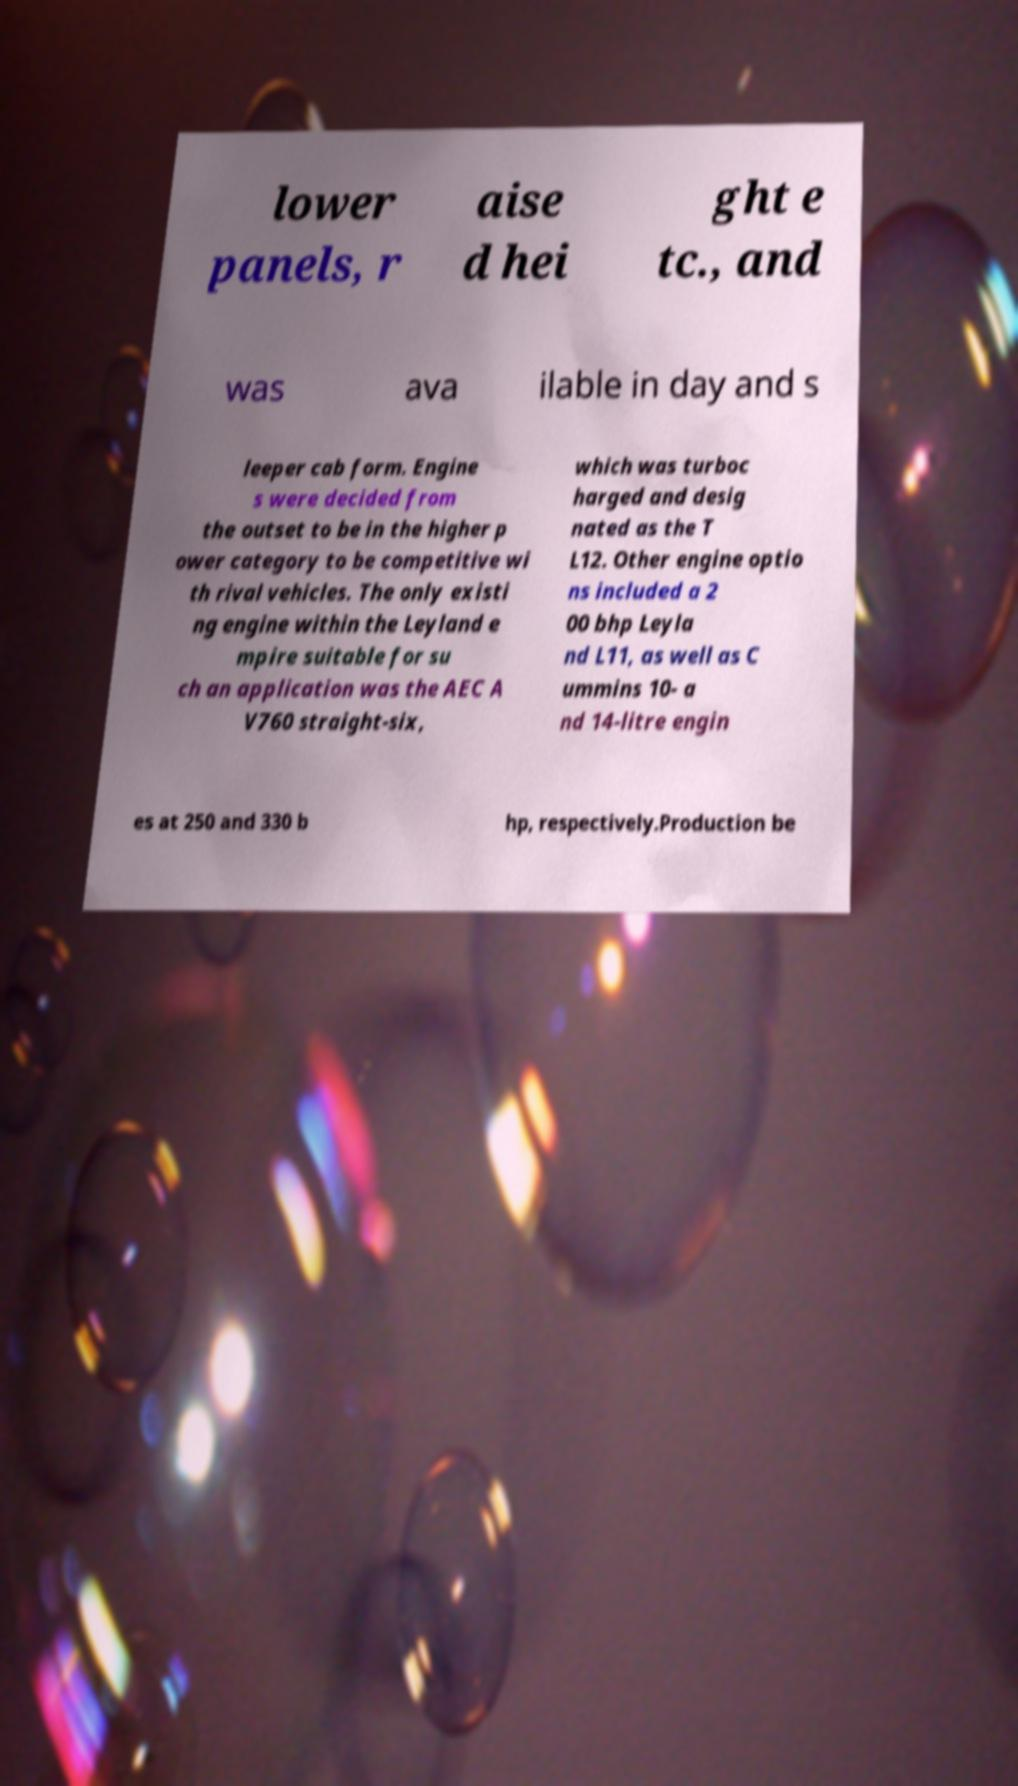Can you accurately transcribe the text from the provided image for me? lower panels, r aise d hei ght e tc., and was ava ilable in day and s leeper cab form. Engine s were decided from the outset to be in the higher p ower category to be competitive wi th rival vehicles. The only existi ng engine within the Leyland e mpire suitable for su ch an application was the AEC A V760 straight-six, which was turboc harged and desig nated as the T L12. Other engine optio ns included a 2 00 bhp Leyla nd L11, as well as C ummins 10- a nd 14-litre engin es at 250 and 330 b hp, respectively.Production be 